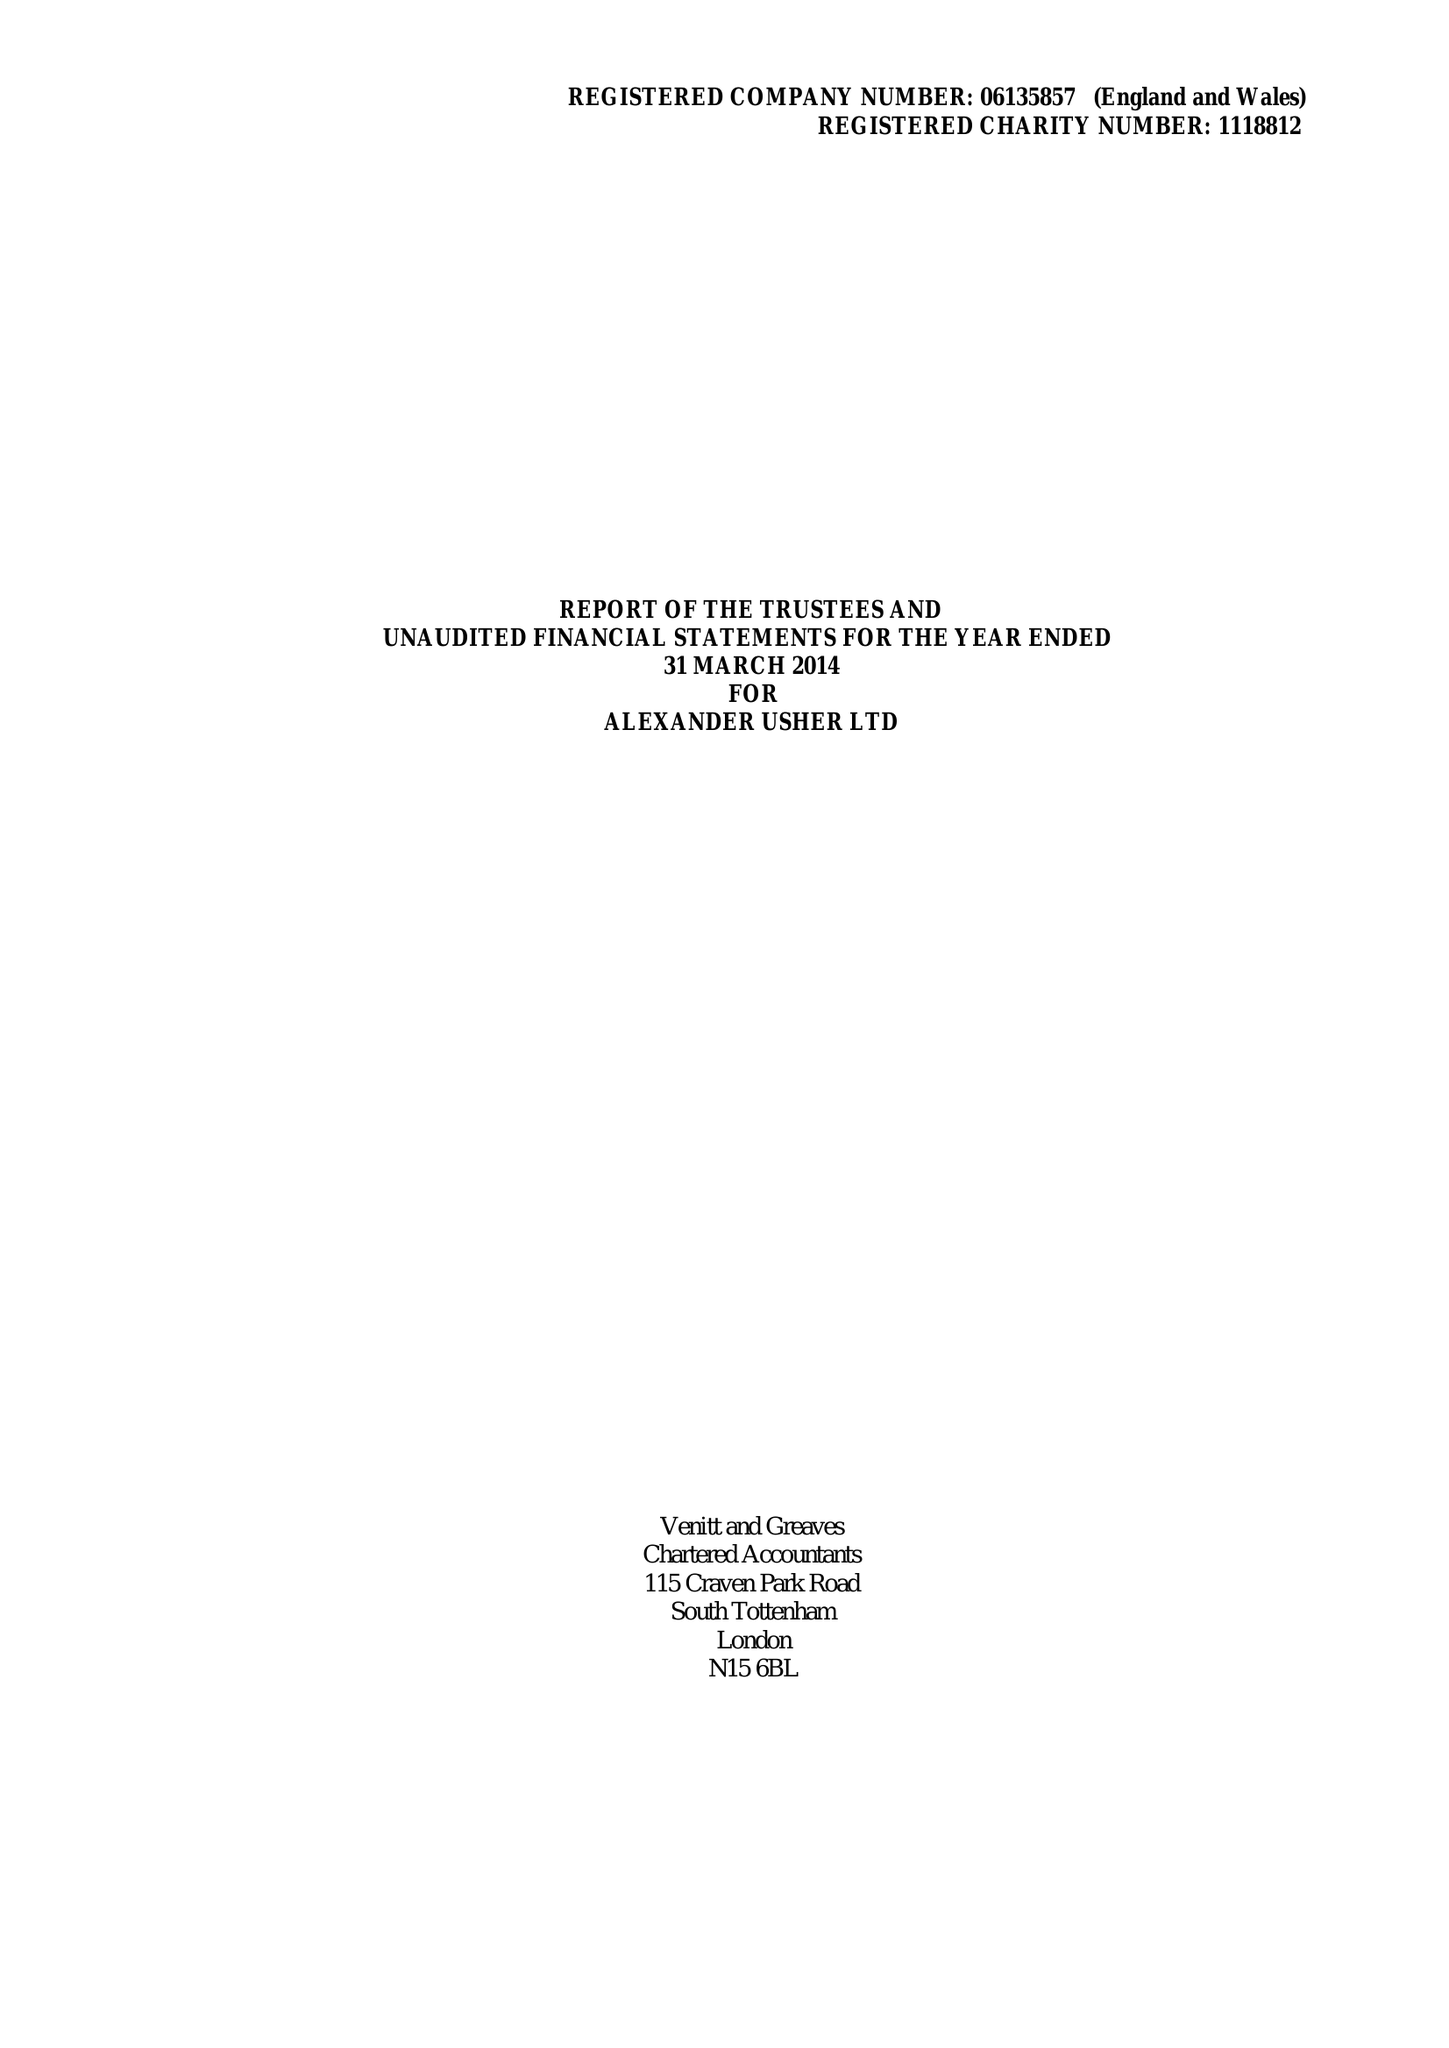What is the value for the address__post_town?
Answer the question using a single word or phrase. LONDON 